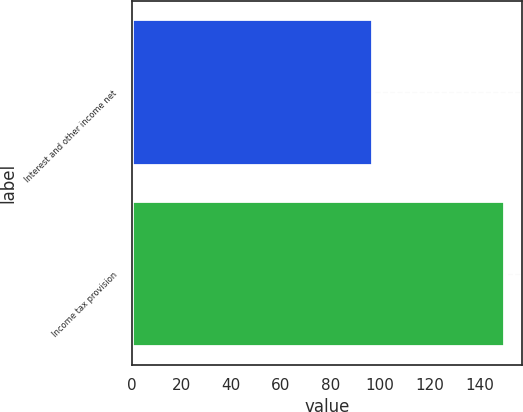Convert chart. <chart><loc_0><loc_0><loc_500><loc_500><bar_chart><fcel>Interest and other income net<fcel>Income tax provision<nl><fcel>96.8<fcel>149.8<nl></chart> 